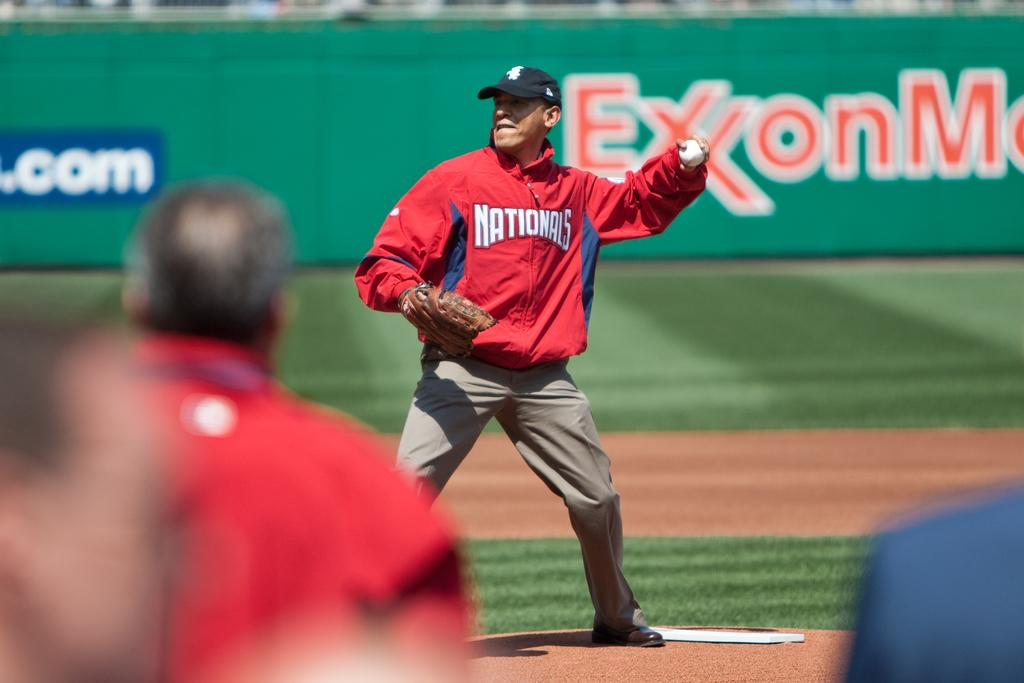<image>
Present a compact description of the photo's key features. Obama is pitching in front of a banner that has Exxon logo. 